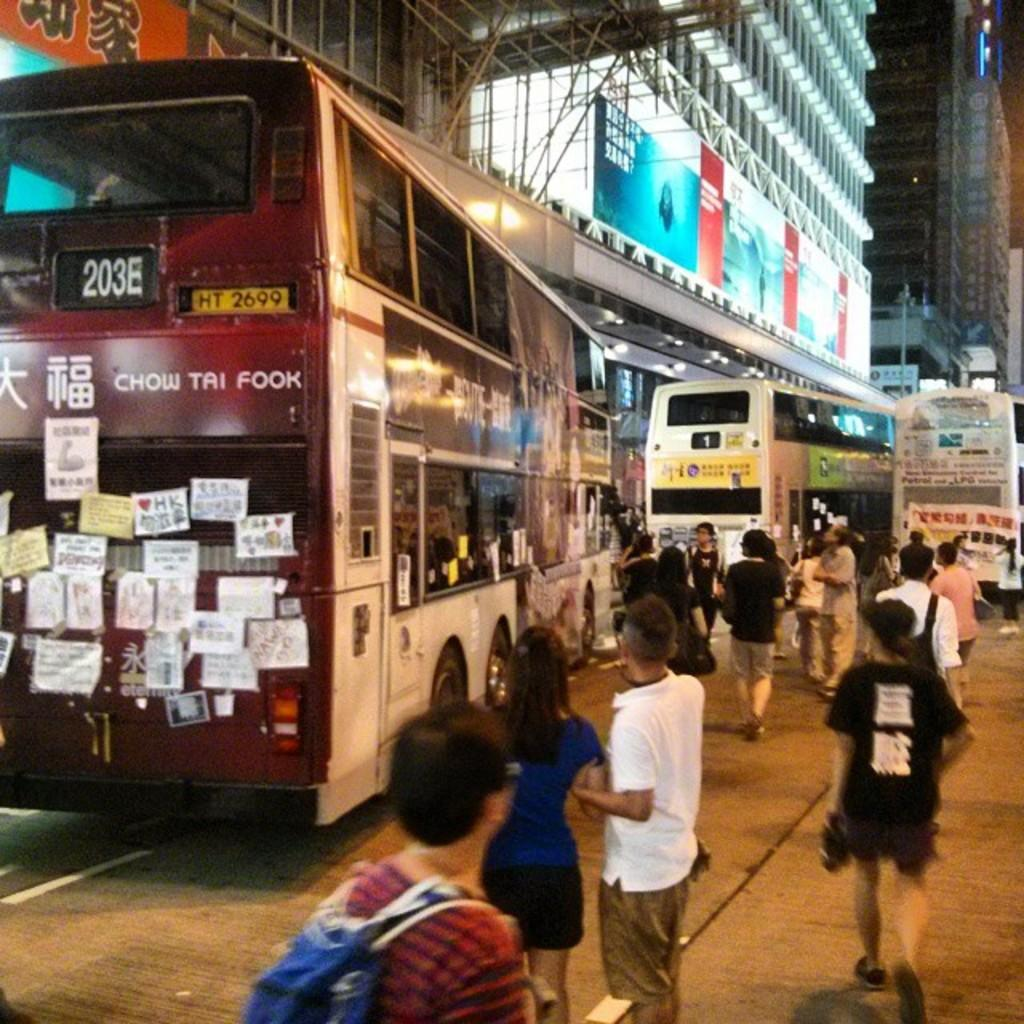<image>
Offer a succinct explanation of the picture presented. Large Bus that has the number 203E on the back with words saying: Chow Tai Fook. 